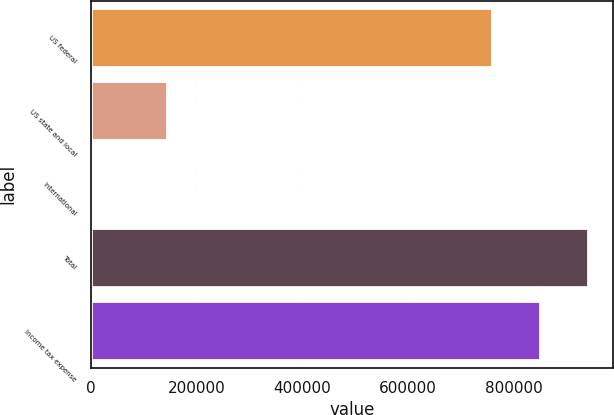Convert chart. <chart><loc_0><loc_0><loc_500><loc_500><bar_chart><fcel>US federal<fcel>US state and local<fcel>International<fcel>Total<fcel>Income tax expense<nl><fcel>759683<fcel>143610<fcel>3415<fcel>940342<fcel>850012<nl></chart> 